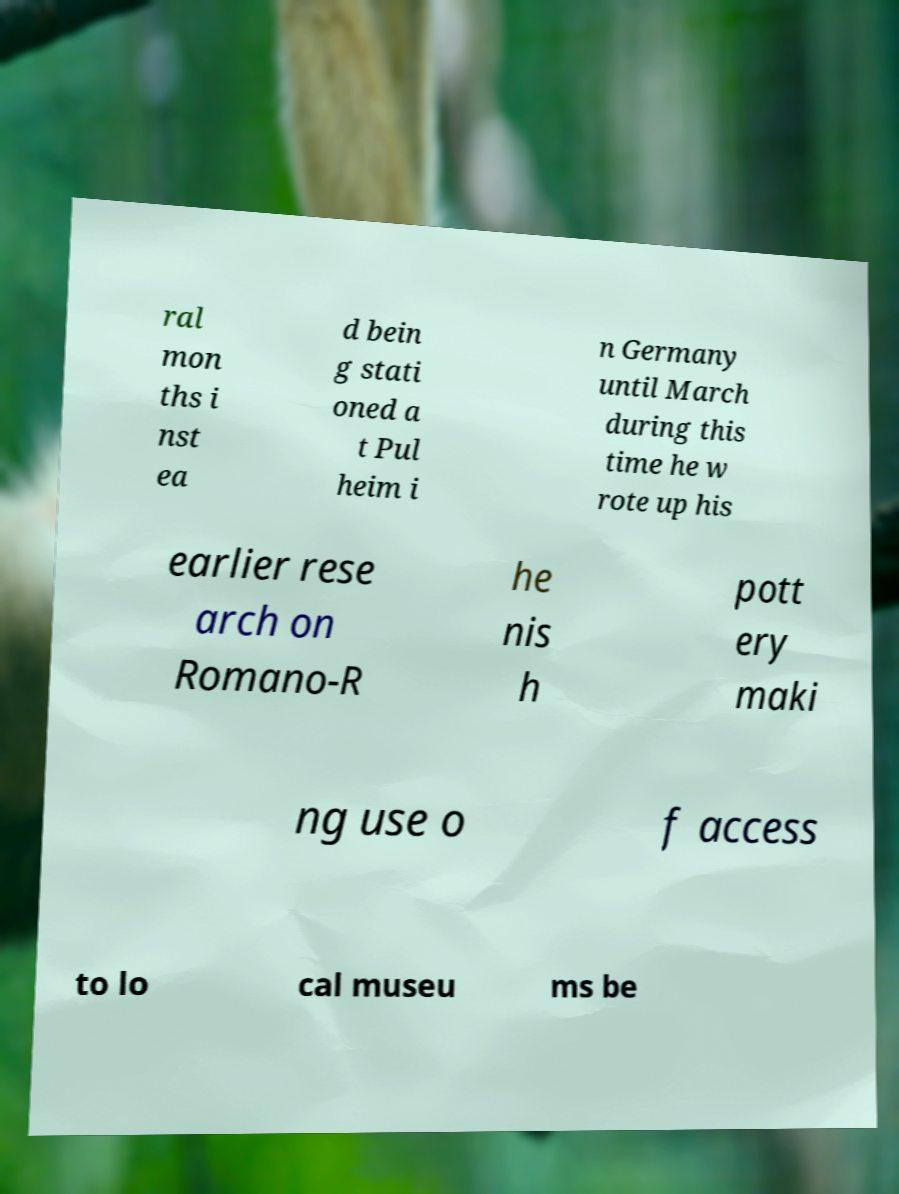There's text embedded in this image that I need extracted. Can you transcribe it verbatim? ral mon ths i nst ea d bein g stati oned a t Pul heim i n Germany until March during this time he w rote up his earlier rese arch on Romano-R he nis h pott ery maki ng use o f access to lo cal museu ms be 